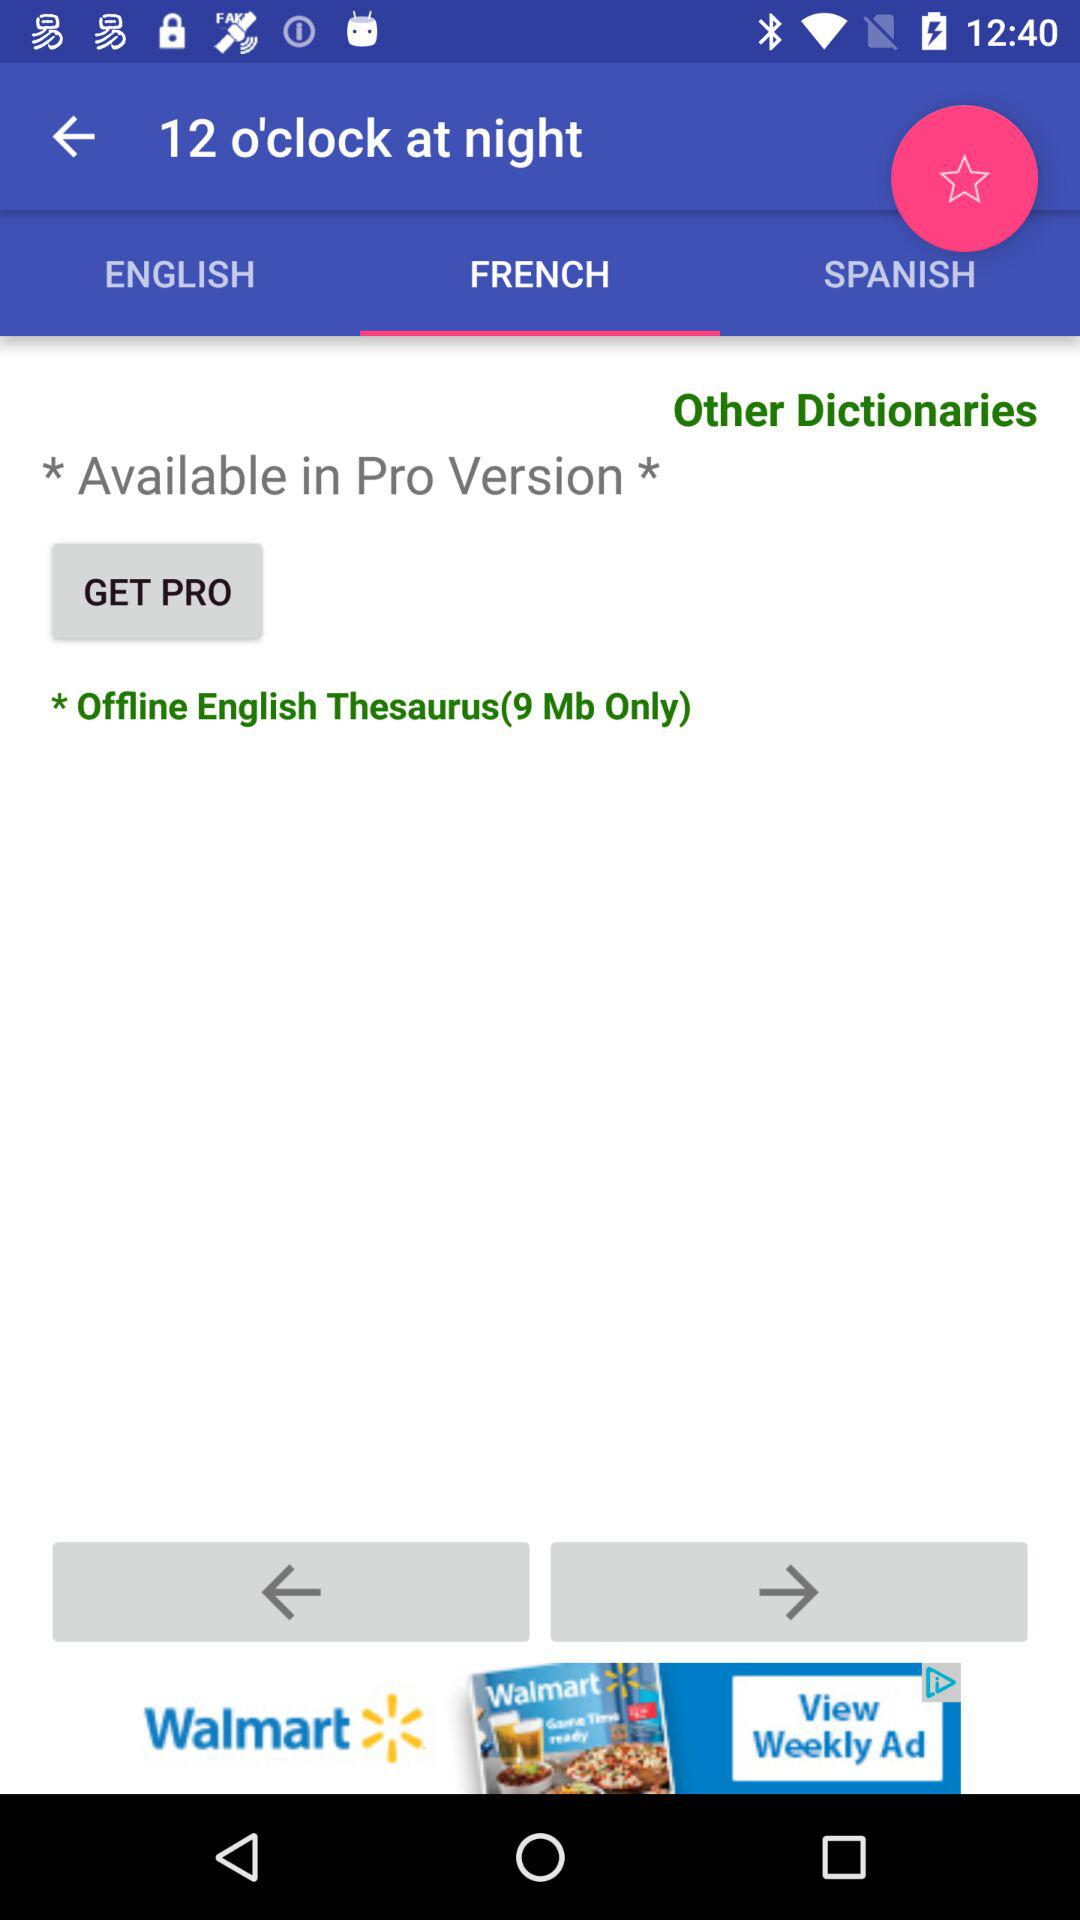Which language is selected? The selected language is French. 